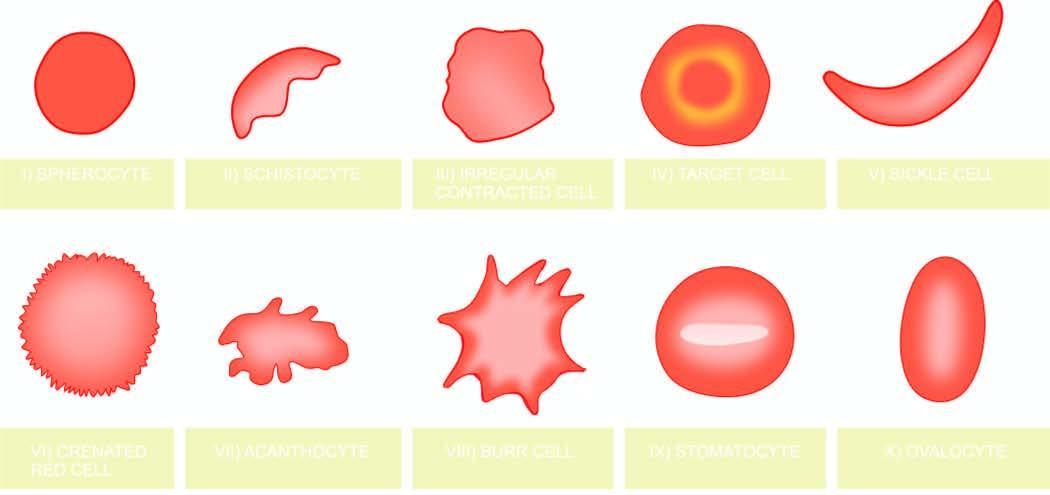do the serial numbers in the illustrations correspond to the order in which they are described in the text?
Answer the question using a single word or phrase. Yes 